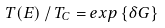<formula> <loc_0><loc_0><loc_500><loc_500>T ( E ) \, / \, T _ { C } = e x p \left \{ \delta G \right \}</formula> 